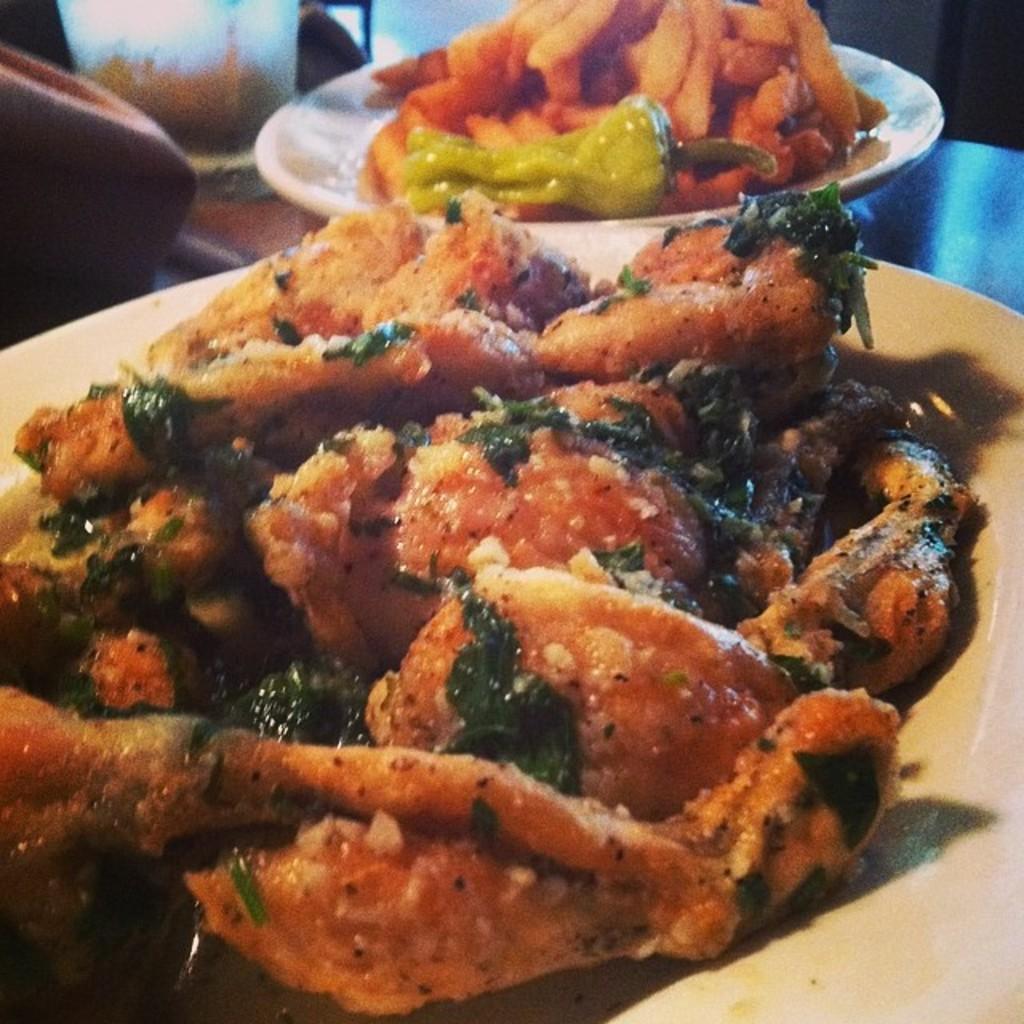Can you describe this image briefly? In this picture I can see food items on the plates, and there are some other items on an object. 